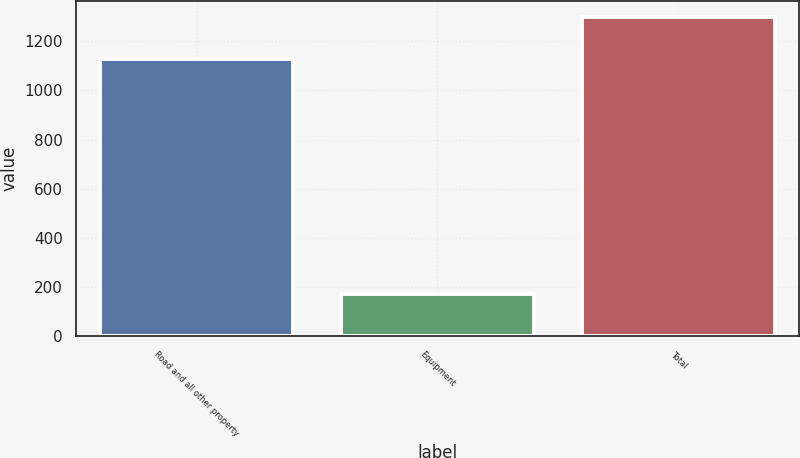<chart> <loc_0><loc_0><loc_500><loc_500><bar_chart><fcel>Road and all other property<fcel>Equipment<fcel>Total<nl><fcel>1128<fcel>171<fcel>1299<nl></chart> 